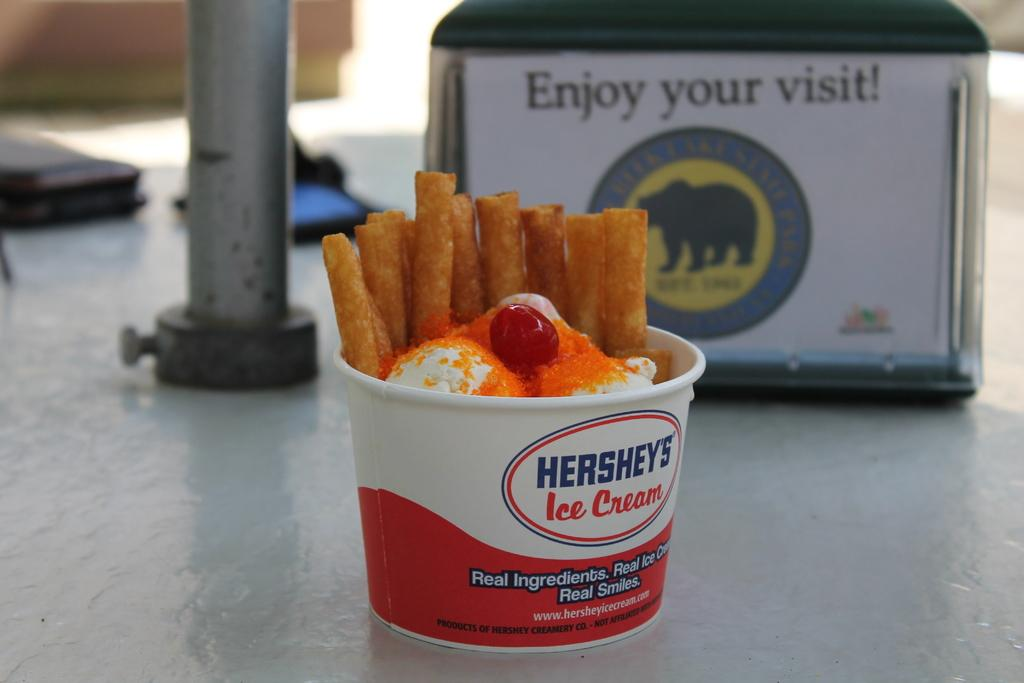What is contained in the cup that is visible in the image? There is food in a cup in the image. What can be seen behind the cup? There is a metal rod visible behind the cup. Can you describe any other objects present in the image? Unfortunately, the provided facts do not specify the nature of the other objects present in the image. Can you see any wilderness in the image? There is no mention of wilderness in the provided facts, so it cannot be seen in the image. 